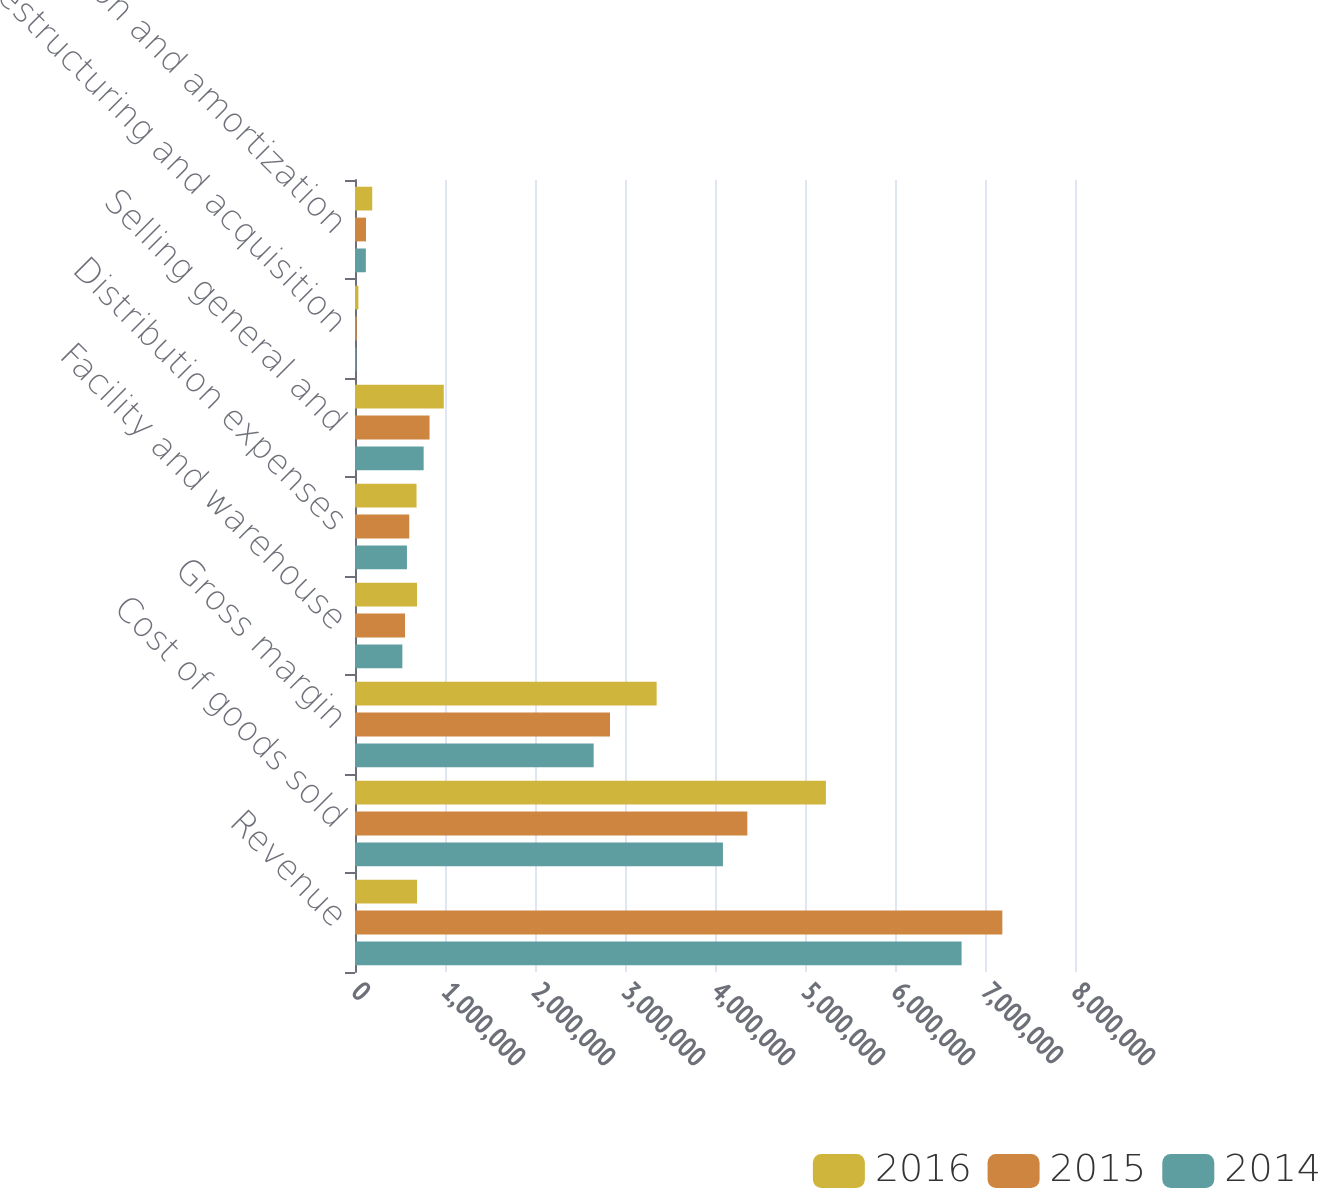<chart> <loc_0><loc_0><loc_500><loc_500><stacked_bar_chart><ecel><fcel>Revenue<fcel>Cost of goods sold<fcel>Gross margin<fcel>Facility and warehouse<fcel>Distribution expenses<fcel>Selling general and<fcel>Restructuring and acquisition<fcel>Depreciation and amortization<nl><fcel>2016<fcel>688918<fcel>5.23233e+06<fcel>3.3517e+06<fcel>688918<fcel>683812<fcel>986380<fcel>37762<fcel>191433<nl><fcel>2015<fcel>7.19263e+06<fcel>4.3591e+06<fcel>2.83353e+06<fcel>556041<fcel>602897<fcel>828333<fcel>19511<fcel>122120<nl><fcel>2014<fcel>6.74006e+06<fcel>4.08815e+06<fcel>2.65191e+06<fcel>526291<fcel>577341<fcel>762888<fcel>14806<fcel>120719<nl></chart> 